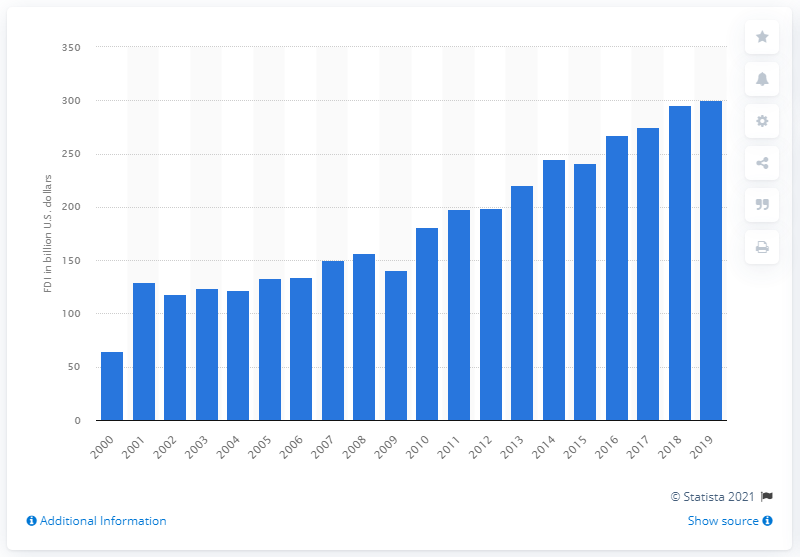Mention a couple of crucial points in this snapshot. In 2019, the amount of Swiss foreign direct investments in the United States was 300.39. 